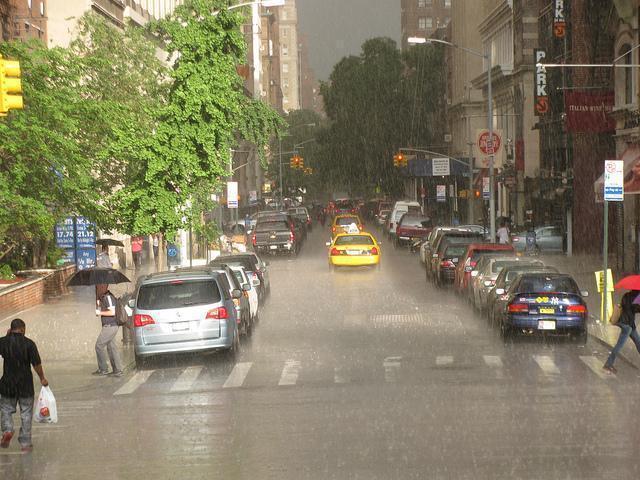What type markings are shown here?
From the following set of four choices, select the accurate answer to respond to the question.
Options: Cross walk, stop message, zoo ads, abbey road. Cross walk. 